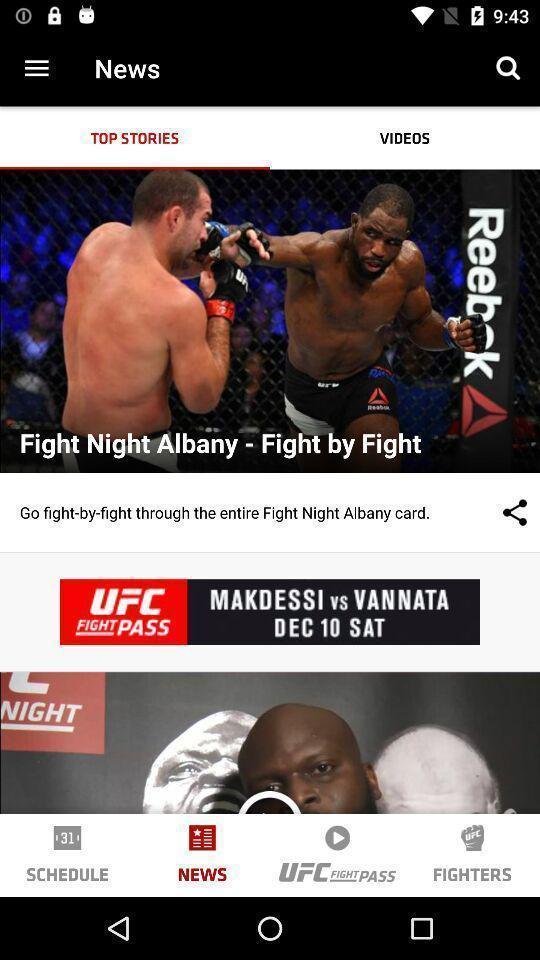Describe the visual elements of this screenshot. Top stories in a sports news app. 